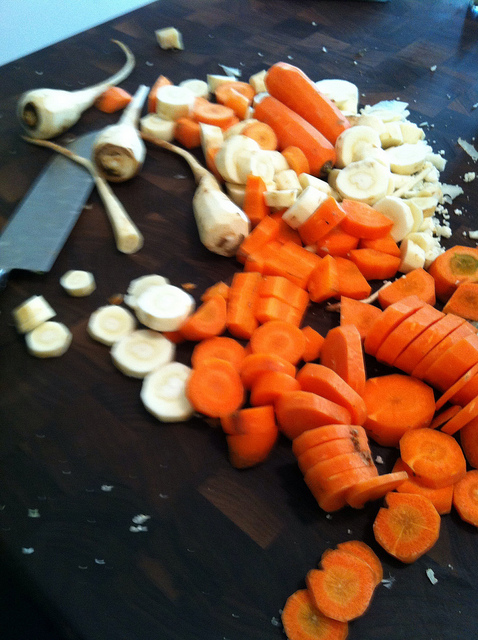<image>What other vegetables are there besides carrots? It's not clear what other vegetables are there besides carrots. However, it can be onion, garlic, parsnips, turnips, or zucchini. What other vegetables are there besides carrots? I don't know what other vegetables are there besides carrots. It can be onion, garlic, parsnips, turnips, zucchini or none of them. 